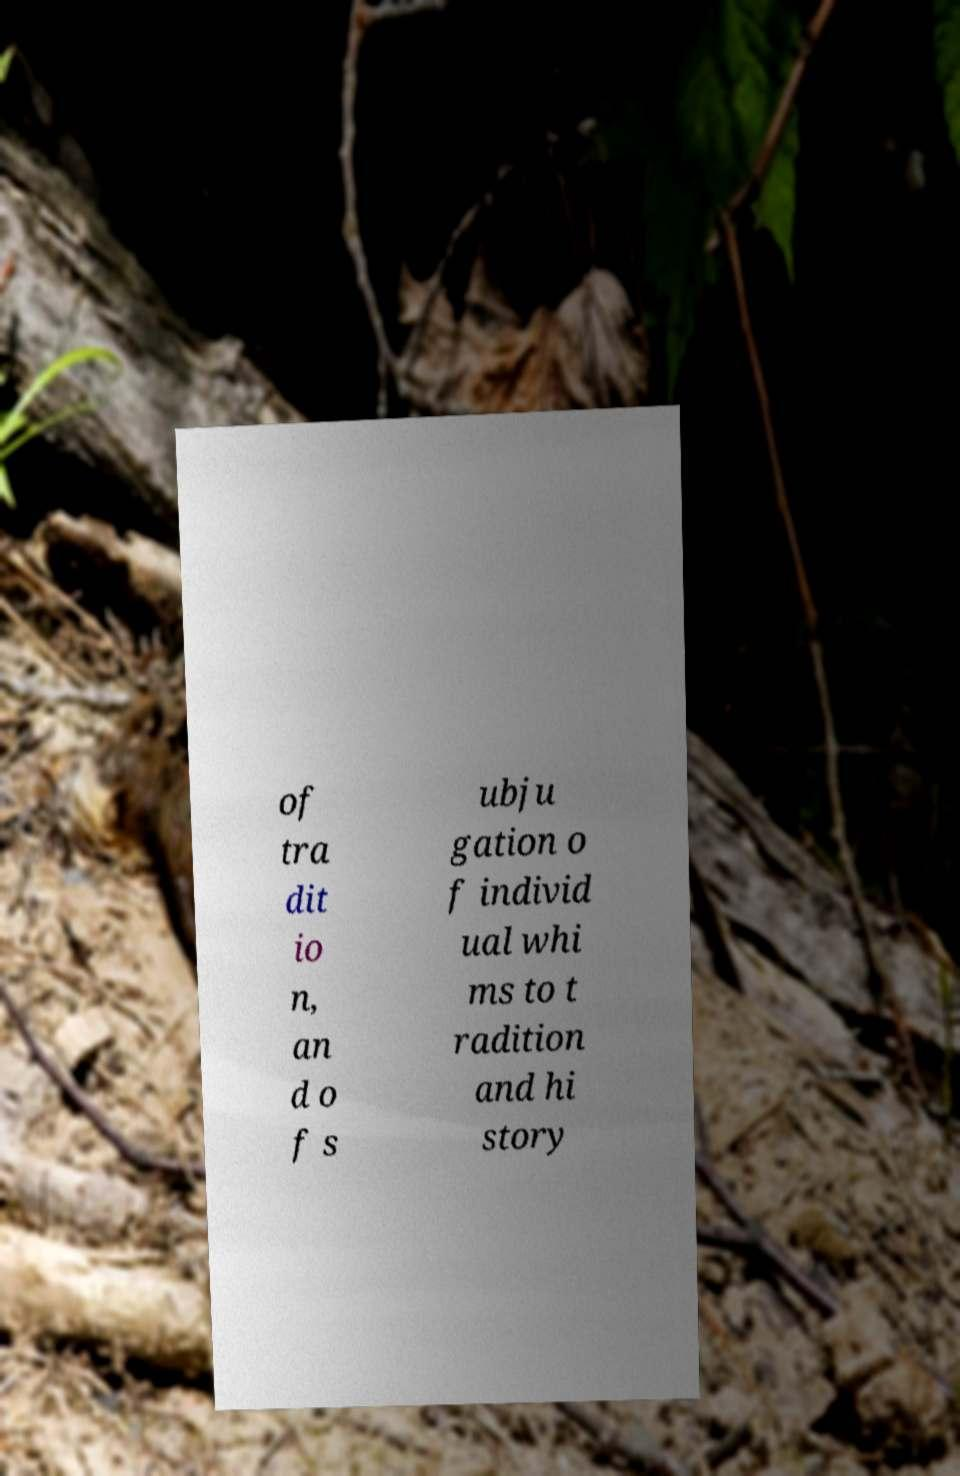Please read and relay the text visible in this image. What does it say? of tra dit io n, an d o f s ubju gation o f individ ual whi ms to t radition and hi story 